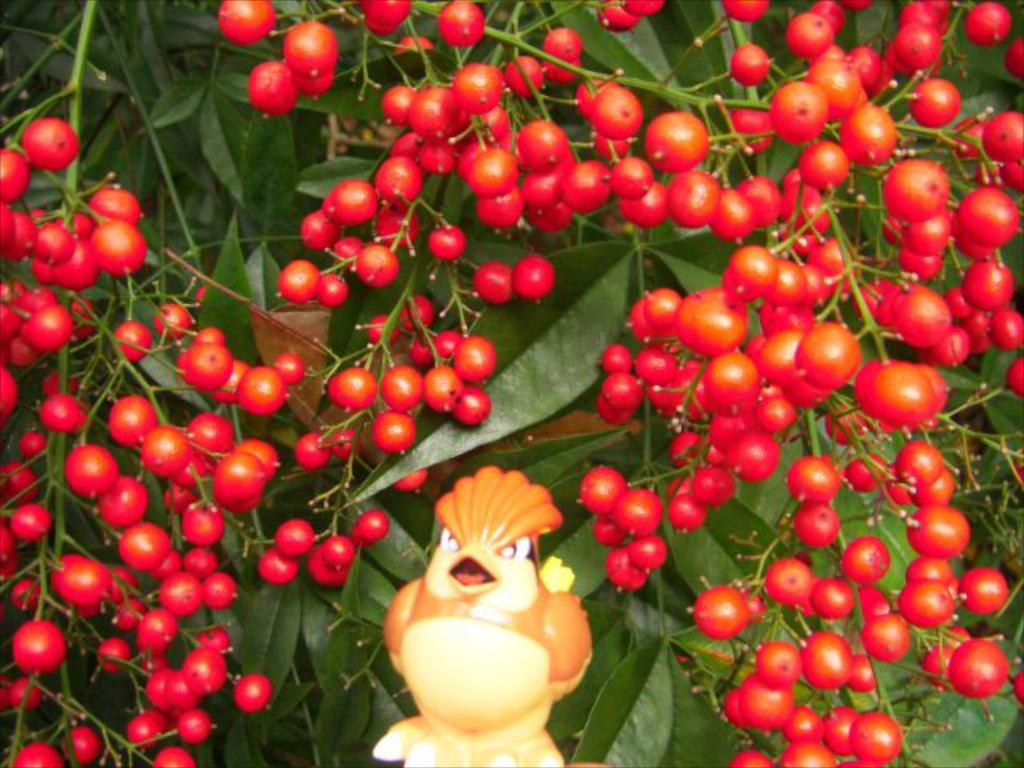What type of food items are present in the image? The image contains fruits. What other elements can be seen in the image besides the fruits? There are leaves and stems of a tree in the image. Can you describe the object in the center of the image? There is a hen-like object in the center of the image. What is the title of the book that is being read by the person in the image? There is no person or book present in the image; it contains fruits, leaves, stems, and a hen-like object. 